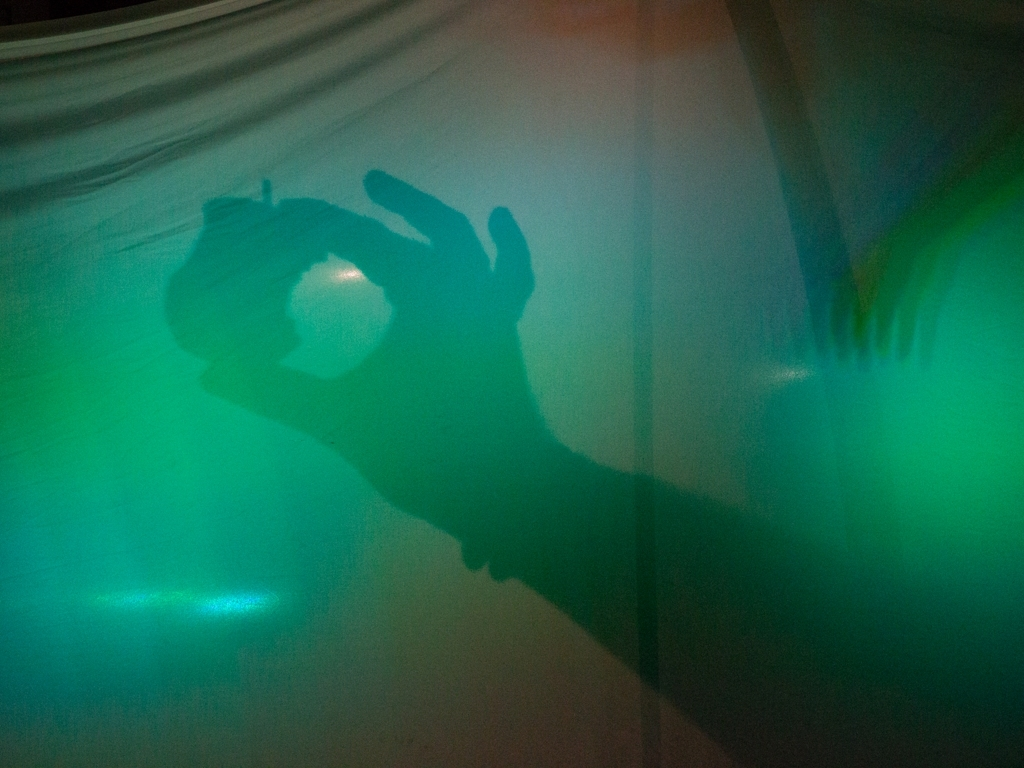How does the color palette of the image contribute to its mood? The cool green and blue hues in the image contribute significantly to its mood, giving it a serene yet slightly eerie atmosphere. This color choice can influence the viewer’s perception, aligning more with feelings of calmness intertwined with an air of mystique. Could the image be used effectively in a particular genre of storytelling? Yes, this image could be quite effective in genres like thriller, horror, or mystery. The dramatic play of shadows and the stark use of color can serve as powerful visual tools to evoke tension and intrigue in narratives within these genres. 